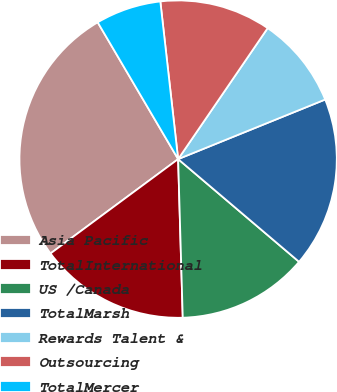Convert chart. <chart><loc_0><loc_0><loc_500><loc_500><pie_chart><fcel>Asia Pacific<fcel>TotalInternational<fcel>US /Canada<fcel>TotalMarsh<fcel>Rewards Talent &<fcel>Outsourcing<fcel>TotalMercer<nl><fcel>26.67%<fcel>15.33%<fcel>13.33%<fcel>17.33%<fcel>9.33%<fcel>11.33%<fcel>6.67%<nl></chart> 